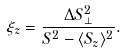<formula> <loc_0><loc_0><loc_500><loc_500>\xi _ { z } = \frac { \Delta S _ { \perp } ^ { 2 } } { S ^ { 2 } - \langle { S _ { z } } \rangle ^ { 2 } } .</formula> 